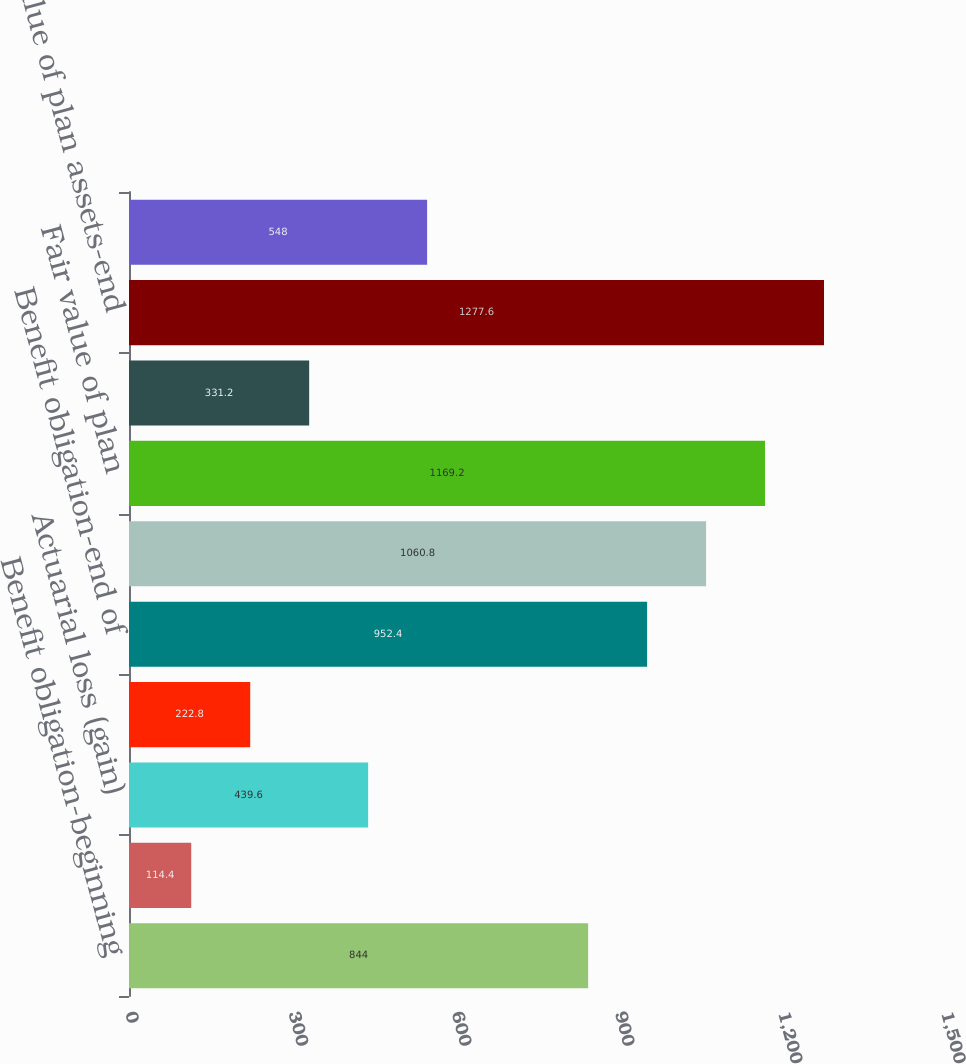Convert chart to OTSL. <chart><loc_0><loc_0><loc_500><loc_500><bar_chart><fcel>Benefit obligation-beginning<fcel>Interest cost<fcel>Actuarial loss (gain)<fcel>Benefit payments<fcel>Benefit obligation-end of<fcel>Accumulated benefit obligation<fcel>Fair value of plan<fcel>Actual return on plan assets<fcel>Fair value of plan assets-end<fcel>Funded status at end of fiscal<nl><fcel>844<fcel>114.4<fcel>439.6<fcel>222.8<fcel>952.4<fcel>1060.8<fcel>1169.2<fcel>331.2<fcel>1277.6<fcel>548<nl></chart> 